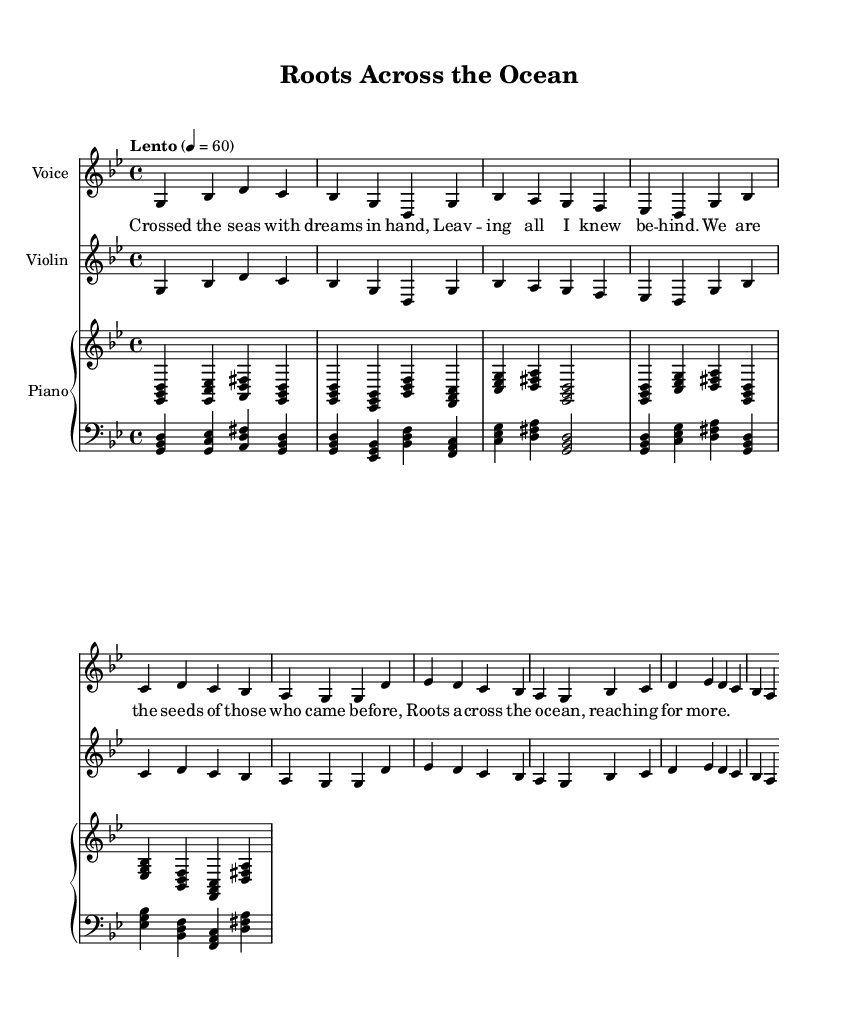What is the key signature of this music? The key signature is G minor, which is indicated by two flats (B flat and E flat) in the key signature section of the sheet music.
Answer: G minor What is the time signature of this music? The time signature is 4/4, which means that there are four beats per measure, and each beat is a quarter note. This is clearly shown at the beginning of the music score.
Answer: 4/4 What is the tempo marking of the music? The tempo marking is "Lento," which indicates a slow tempo, typically around 60 beats per minute. This is specified at the start of the score.
Answer: Lento How many measures are in the intro section? The intro consists of 4 measures, as seen by counting the distinct groups of musical notation leading up to the first verse.
Answer: 4 What is the first lyric of the verse? The first lyric of the verse is "Crossed the seas with dreams in hand," which is displayed beneath the corresponding notes in the voice staff.
Answer: Crossed the seas with dreams in hand Which instrument plays the harmony throughout the song? The piano plays the harmony throughout the song, as indicated by its continuous accompaniment of chords beneath the melodic lines in both the voice and violin parts.
Answer: Piano What is the primary theme of the chorus? The primary theme of the chorus speaks to the immigrant experience, focusing on heritage and longing, as reflected in the lyrics "We are the seeds of those who came before."
Answer: Roots across the ocean 